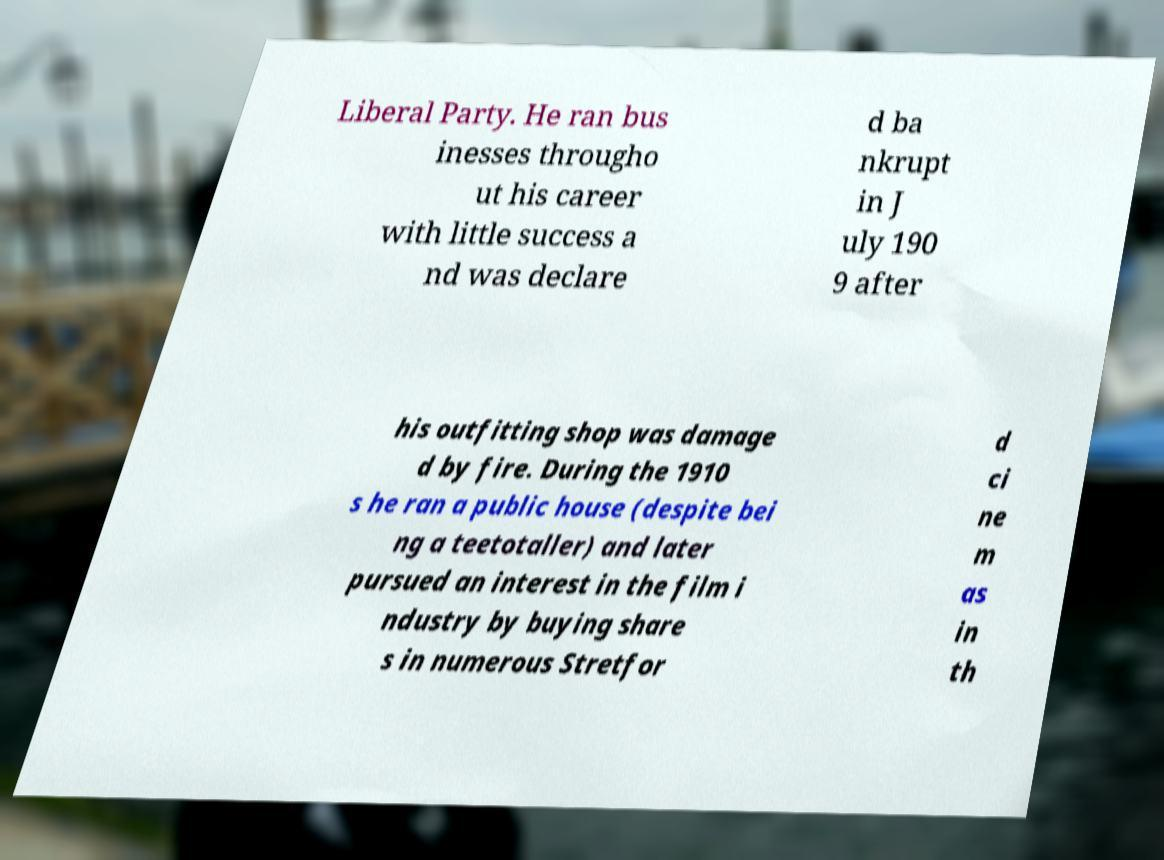Can you accurately transcribe the text from the provided image for me? Liberal Party. He ran bus inesses througho ut his career with little success a nd was declare d ba nkrupt in J uly 190 9 after his outfitting shop was damage d by fire. During the 1910 s he ran a public house (despite bei ng a teetotaller) and later pursued an interest in the film i ndustry by buying share s in numerous Stretfor d ci ne m as in th 